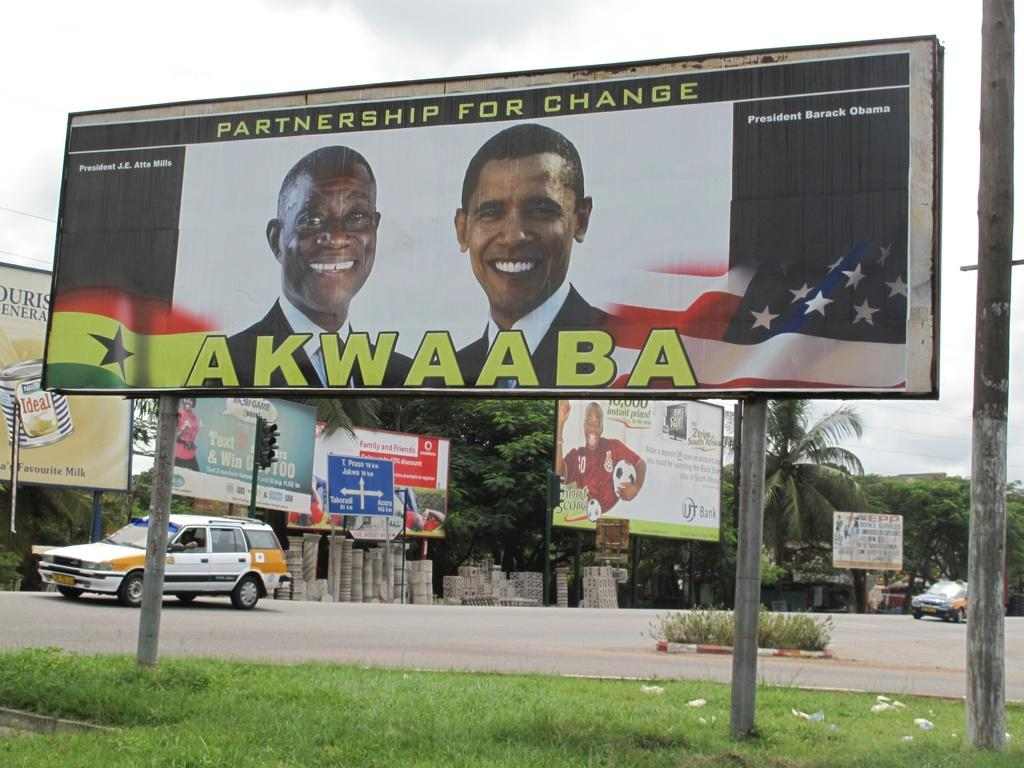<image>
Summarize the visual content of the image. A billboard has a photo of two black men with title shown to say 'Parternership for Change' at the top and Akwaaba at the bottom. 